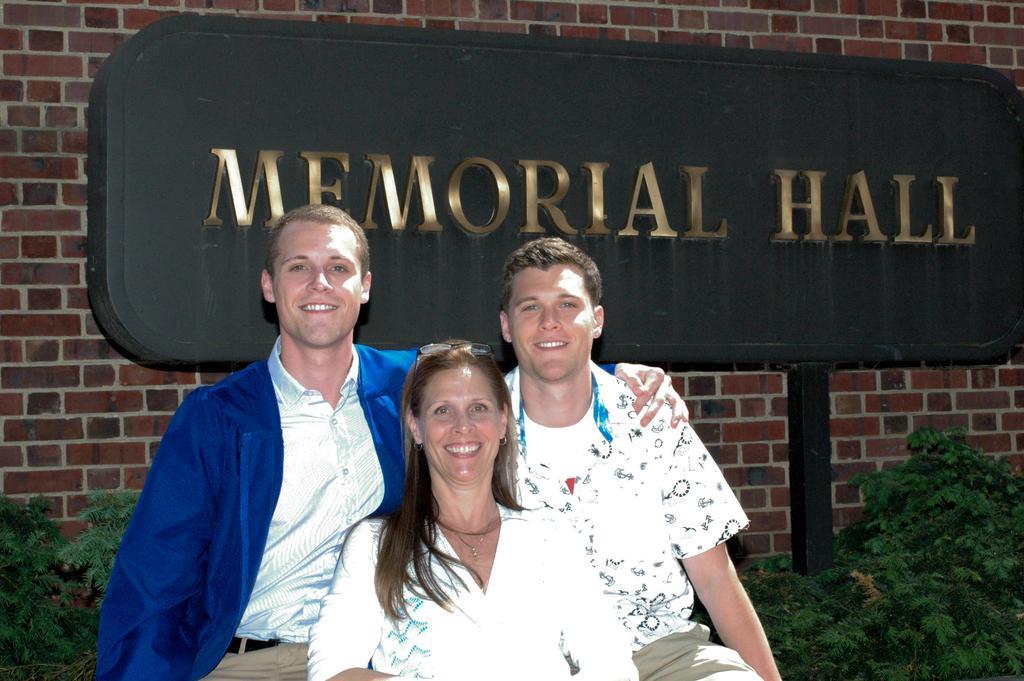Describe this image in one or two sentences. In the picture we can see a woman and two men are sitting, they are wearing a white shirt which are shining and one man is wearing a blue color blazer on the shirt and in the background, we can see a wall which is in the kind of bricks and a board near it, and name on it we can see memorial hall, near to the board we can see some plants. 